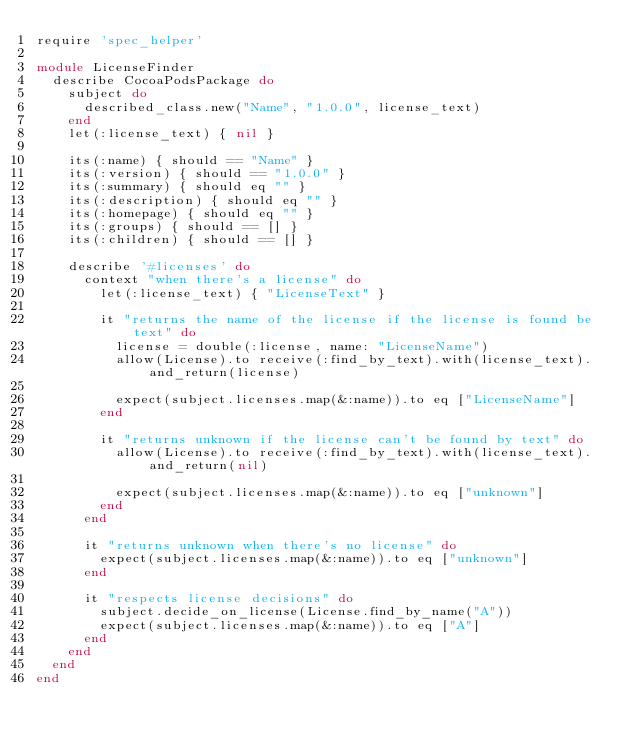<code> <loc_0><loc_0><loc_500><loc_500><_Ruby_>require 'spec_helper'

module LicenseFinder
  describe CocoaPodsPackage do
    subject do
      described_class.new("Name", "1.0.0", license_text)
    end
    let(:license_text) { nil }

    its(:name) { should == "Name" }
    its(:version) { should == "1.0.0" }
    its(:summary) { should eq "" }
    its(:description) { should eq "" }
    its(:homepage) { should eq "" }
    its(:groups) { should == [] }
    its(:children) { should == [] }

    describe '#licenses' do
      context "when there's a license" do
        let(:license_text) { "LicenseText" }

        it "returns the name of the license if the license is found be text" do
          license = double(:license, name: "LicenseName")
          allow(License).to receive(:find_by_text).with(license_text).and_return(license)

          expect(subject.licenses.map(&:name)).to eq ["LicenseName"]
        end

        it "returns unknown if the license can't be found by text" do
          allow(License).to receive(:find_by_text).with(license_text).and_return(nil)

          expect(subject.licenses.map(&:name)).to eq ["unknown"]
        end
      end

      it "returns unknown when there's no license" do
        expect(subject.licenses.map(&:name)).to eq ["unknown"]
      end

      it "respects license decisions" do
        subject.decide_on_license(License.find_by_name("A"))
        expect(subject.licenses.map(&:name)).to eq ["A"]
      end
    end
  end
end

</code> 